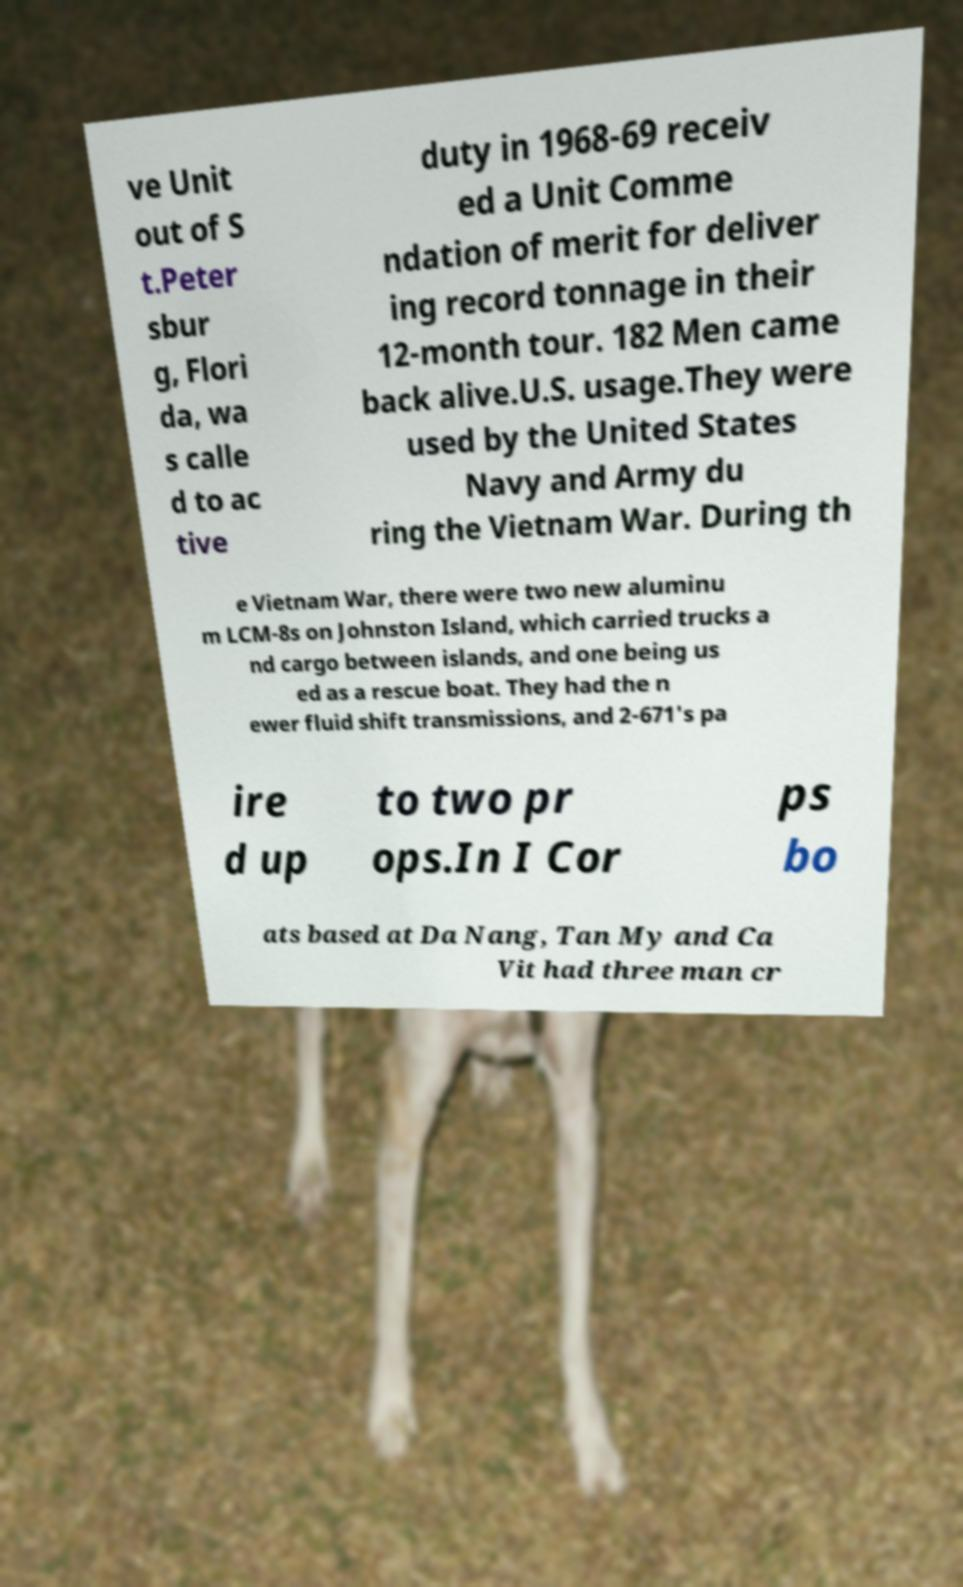Please identify and transcribe the text found in this image. ve Unit out of S t.Peter sbur g, Flori da, wa s calle d to ac tive duty in 1968-69 receiv ed a Unit Comme ndation of merit for deliver ing record tonnage in their 12-month tour. 182 Men came back alive.U.S. usage.They were used by the United States Navy and Army du ring the Vietnam War. During th e Vietnam War, there were two new aluminu m LCM-8s on Johnston Island, which carried trucks a nd cargo between islands, and one being us ed as a rescue boat. They had the n ewer fluid shift transmissions, and 2-671's pa ire d up to two pr ops.In I Cor ps bo ats based at Da Nang, Tan My and Ca Vit had three man cr 